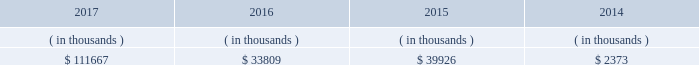System energy may refinance , redeem , or otherwise retire debt prior to maturity , to the extent market conditions and interest and dividend rates are favorable .
All debt and common stock issuances by system energy require prior regulatory approval . a0 a0debt issuances are also subject to issuance tests set forth in its bond indentures and other agreements . a0 a0system energy has sufficient capacity under these tests to meet its foreseeable capital needs .
System energy 2019s receivables from the money pool were as follows as of december 31 for each of the following years. .
See note 4 to the financial statements for a description of the money pool .
The system energy nuclear fuel company variable interest entity has a credit facility in the amount of $ 120 million scheduled to expire in may 2019 .
As of december 31 , 2017 , $ 17.8 million in letters of credit to support a like amount of commercial paper issued and $ 50 million in loans were outstanding under the system energy nuclear fuel company variable interest entity credit facility .
See note 4 to the financial statements for additional discussion of the variable interest entity credit facility .
System energy obtained authorizations from the ferc through october 2019 for the following : 2022 short-term borrowings not to exceed an aggregate amount of $ 200 million at any time outstanding ; 2022 long-term borrowings and security issuances ; and 2022 long-term borrowings by its nuclear fuel company variable interest entity .
See note 4 to the financial statements for further discussion of system energy 2019s short-term borrowing limits .
System energy resources , inc .
Management 2019s financial discussion and analysis federal regulation see the 201crate , cost-recovery , and other regulation 2013 federal regulation 201d section of entergy corporation and subsidiaries management 2019s financial discussion and analysis and note 2 to the financial statements for a discussion of federal regulation .
Complaint against system energy in january 2017 the apsc and mpsc filed a complaint with the ferc against system energy .
The complaint seeks a reduction in the return on equity component of the unit power sales agreement pursuant to which system energy sells its grand gulf capacity and energy to entergy arkansas , entergy louisiana , entergy mississippi , and entergy new orleans .
Entergy arkansas also sells some of its grand gulf capacity and energy to entergy louisiana , entergy mississippi , and entergy new orleans under separate agreements .
The current return on equity under the unit power sales agreement is 10.94% ( 10.94 % ) .
The complaint alleges that the return on equity is unjust and unreasonable because current capital market and other considerations indicate that it is excessive .
The complaint requests the ferc to institute proceedings to investigate the return on equity and establish a lower return on equity , and also requests that the ferc establish january 23 , 2017 as a refund effective date .
The complaint includes return on equity analysis that purports to establish that the range of reasonable return on equity for system energy is between 8.37% ( 8.37 % ) and 8.67% ( 8.67 % ) .
System energy answered the complaint in february 2017 and disputes that a return on equity of 8.37% ( 8.37 % ) to 8.67% ( 8.67 % ) is just and reasonable .
The lpsc and the city council intervened in the proceeding expressing support for the complaint .
System energy is recording a provision against revenue for the potential outcome of this proceeding .
In september 2017 the ferc established a refund effective date of january 23 , 2017 , consolidated the return on equity complaint with the proceeding described in unit power sales agreement below , and directed the parties to engage in settlement .
What was the sum of the system energy 2019s receivables from 2014 to 2017? 
Computations: (((111667 + 33809) + 39926) + 2373)
Answer: 187775.0. 